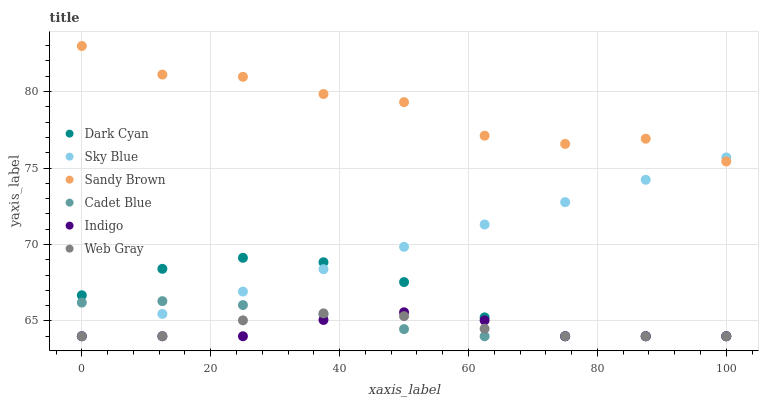Does Indigo have the minimum area under the curve?
Answer yes or no. Yes. Does Sandy Brown have the maximum area under the curve?
Answer yes or no. Yes. Does Web Gray have the minimum area under the curve?
Answer yes or no. No. Does Web Gray have the maximum area under the curve?
Answer yes or no. No. Is Sky Blue the smoothest?
Answer yes or no. Yes. Is Sandy Brown the roughest?
Answer yes or no. Yes. Is Indigo the smoothest?
Answer yes or no. No. Is Indigo the roughest?
Answer yes or no. No. Does Cadet Blue have the lowest value?
Answer yes or no. Yes. Does Sandy Brown have the lowest value?
Answer yes or no. No. Does Sandy Brown have the highest value?
Answer yes or no. Yes. Does Indigo have the highest value?
Answer yes or no. No. Is Dark Cyan less than Sandy Brown?
Answer yes or no. Yes. Is Sandy Brown greater than Web Gray?
Answer yes or no. Yes. Does Sky Blue intersect Indigo?
Answer yes or no. Yes. Is Sky Blue less than Indigo?
Answer yes or no. No. Is Sky Blue greater than Indigo?
Answer yes or no. No. Does Dark Cyan intersect Sandy Brown?
Answer yes or no. No. 